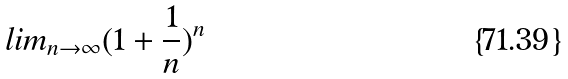Convert formula to latex. <formula><loc_0><loc_0><loc_500><loc_500>l i m _ { n \rightarrow \infty } ( 1 + \frac { 1 } { n } ) ^ { n }</formula> 